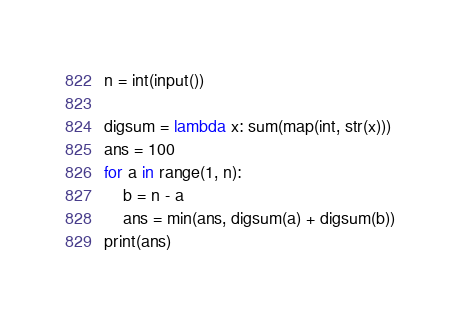Convert code to text. <code><loc_0><loc_0><loc_500><loc_500><_Python_>n = int(input())

digsum = lambda x: sum(map(int, str(x)))
ans = 100
for a in range(1, n):
    b = n - a
    ans = min(ans, digsum(a) + digsum(b))
print(ans)</code> 